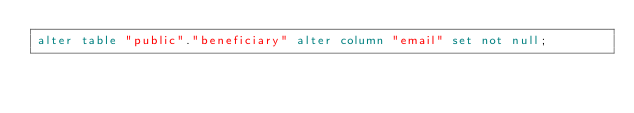<code> <loc_0><loc_0><loc_500><loc_500><_SQL_>alter table "public"."beneficiary" alter column "email" set not null;
</code> 